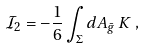<formula> <loc_0><loc_0><loc_500><loc_500>{ \mathcal { I } } _ { 2 } = - \frac { 1 } { 6 } \int _ { \Sigma } d A _ { \bar { g } } \, K \, ,</formula> 